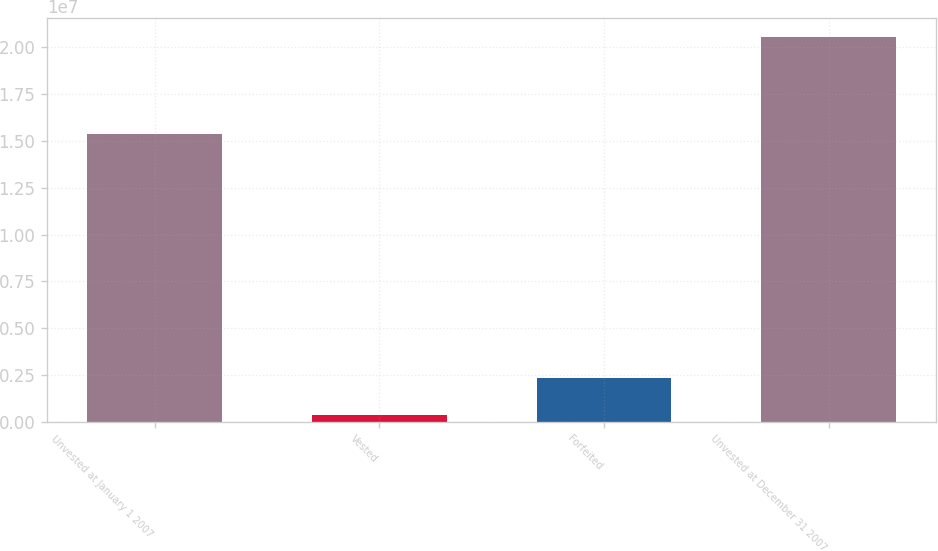Convert chart to OTSL. <chart><loc_0><loc_0><loc_500><loc_500><bar_chart><fcel>Unvested at January 1 2007<fcel>Vested<fcel>Forfeited<fcel>Unvested at December 31 2007<nl><fcel>1.53793e+07<fcel>365454<fcel>2.37948e+06<fcel>2.05057e+07<nl></chart> 